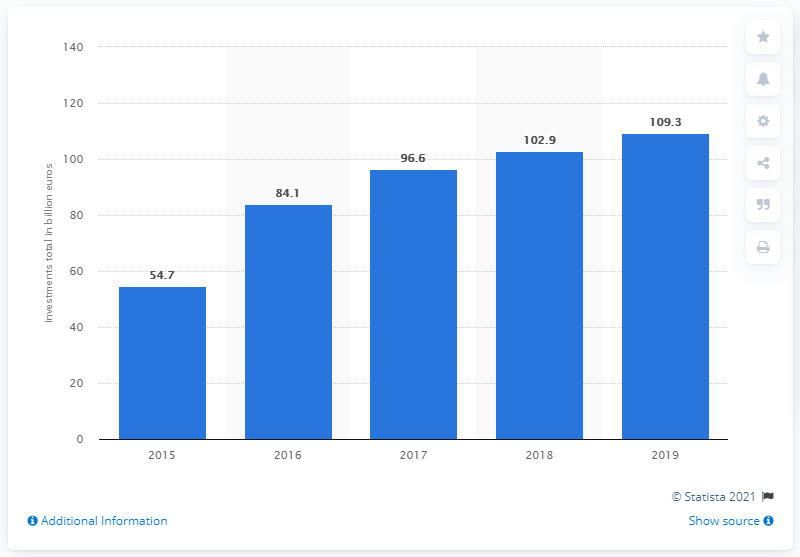Specify some key components in this picture. In 2019, the total amount of private equity funds raised in Europe was 109.3 billion dollars. 